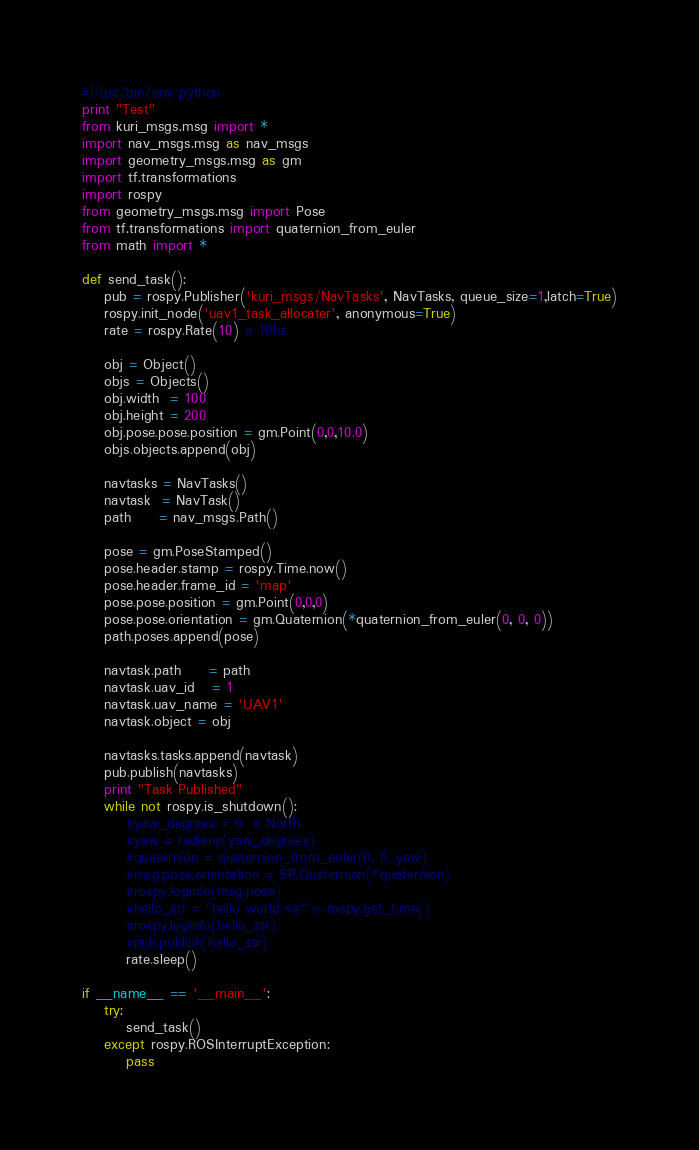Convert code to text. <code><loc_0><loc_0><loc_500><loc_500><_Python_>#!/usr/bin/env python
print "Test"
from kuri_msgs.msg import *
import nav_msgs.msg as nav_msgs
import geometry_msgs.msg as gm
import tf.transformations
import rospy
from geometry_msgs.msg import Pose
from tf.transformations import quaternion_from_euler
from math import *

def send_task():
    pub = rospy.Publisher('kuri_msgs/NavTasks', NavTasks, queue_size=1,latch=True)
    rospy.init_node('uav1_task_allocater', anonymous=True)
    rate = rospy.Rate(10) # 10hz

    obj = Object()
    objs = Objects()
    obj.width  = 100
    obj.height = 200
    obj.pose.pose.position = gm.Point(0,0,10.0)
    objs.objects.append(obj)

    navtasks = NavTasks()
    navtask  = NavTask()
    path     = nav_msgs.Path()

    pose = gm.PoseStamped()
    pose.header.stamp = rospy.Time.now()
    pose.header.frame_id = 'map'
    pose.pose.position = gm.Point(0,0,0)
    pose.pose.orientation = gm.Quaternion(*quaternion_from_euler(0, 0, 0))
    path.poses.append(pose)

    navtask.path     = path
    navtask.uav_id   = 1
    navtask.uav_name = 'UAV1'
    navtask.object = obj

    navtasks.tasks.append(navtask)
    pub.publish(navtasks)
    print "Task Published"
    while not rospy.is_shutdown():
        #yaw_degrees = 0  # North
        #yaw = radians(yaw_degrees)
        #quaternion = quaternion_from_euler(0, 0, yaw)
        #msg.pose.orientation = SP.Quaternion(*quaternion)
        #rospy.loginfo(msg.pose)
        #hello_str = "hello world %s" % rospy.get_time()
        #rospy.loginfo(hello_str)
        #pub.publish(hello_str)
        rate.sleep()

if __name__ == '__main__':
    try:
        send_task()
    except rospy.ROSInterruptException:
        pass</code> 